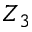<formula> <loc_0><loc_0><loc_500><loc_500>Z _ { 3 }</formula> 